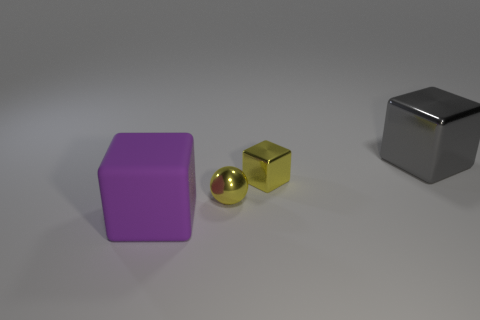Subtract all tiny yellow metallic cubes. How many cubes are left? 2 Add 4 tiny purple objects. How many objects exist? 8 Subtract all spheres. How many objects are left? 3 Add 2 tiny yellow shiny objects. How many tiny yellow shiny objects exist? 4 Subtract 0 blue spheres. How many objects are left? 4 Subtract all blue spheres. Subtract all gray things. How many objects are left? 3 Add 4 small yellow shiny spheres. How many small yellow shiny spheres are left? 5 